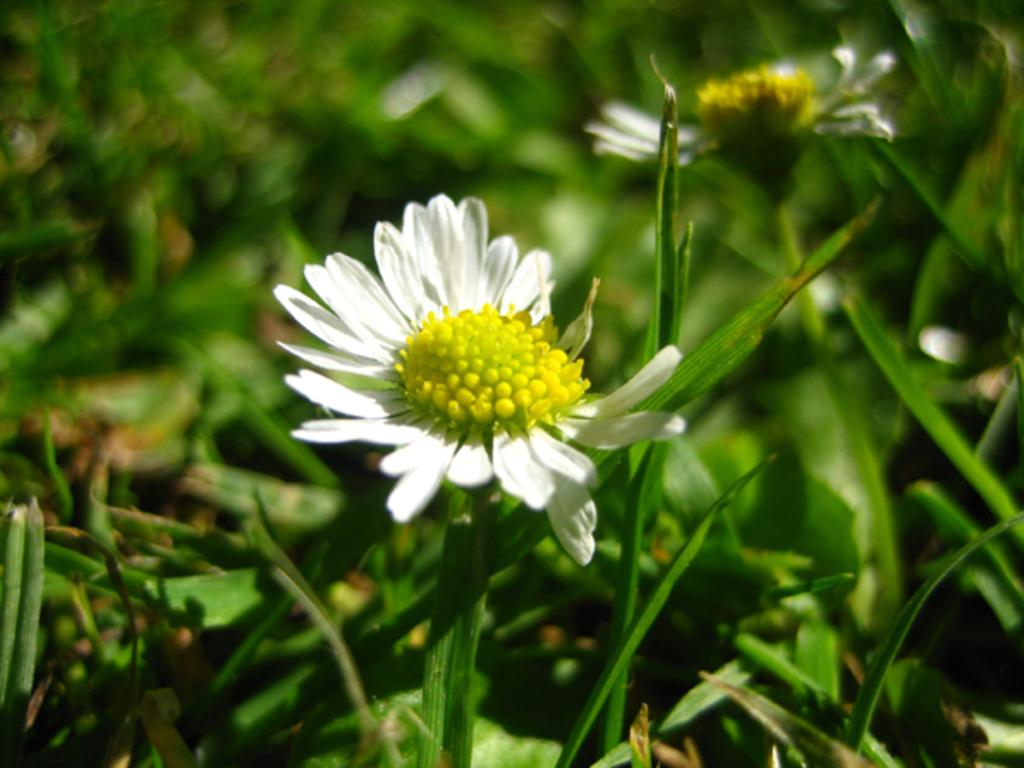What type of living organisms can be seen in the image? There are flowers in the image. What can be seen in the background of the image? There are plants in the background of the image. What time does the clock show in the image? There is no clock present in the image. Can you describe the cow in the image? There is no cow present in the image. 